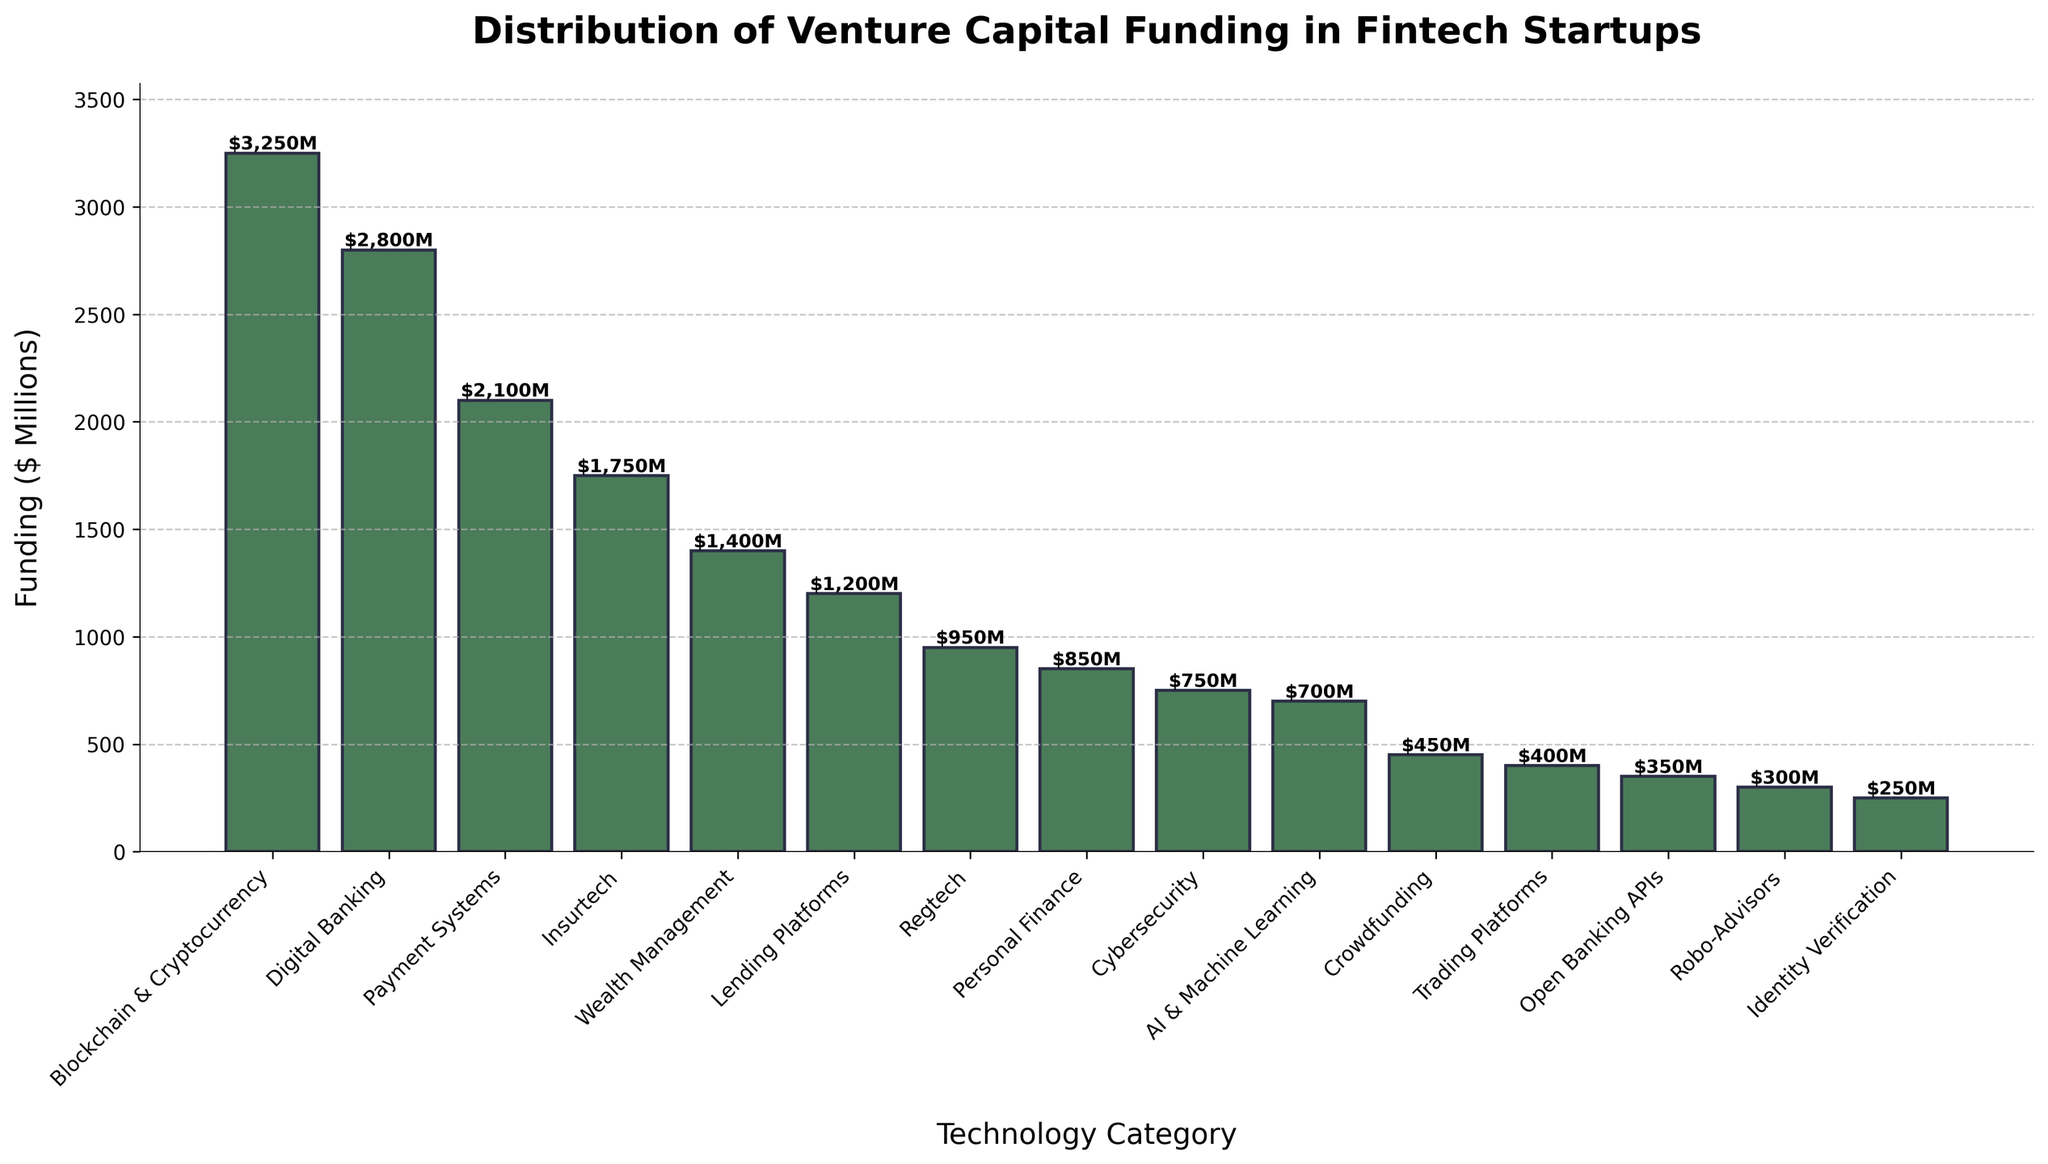What technology category received the most venture capital funding? The category with the tallest bar represents the highest funding. Here, "Blockchain & Cryptocurrency" has the tallest bar indicating it received the most funding.
Answer: Blockchain & Cryptocurrency Which two categories combined have the highest funding? To find the combined funding, add the amounts for different categories. The top two funded categories are "Blockchain & Cryptocurrency" ($3250M) and "Digital Banking" ($2800M). Combining these: $3250M + $2800M = $6050M.
Answer: Blockchain & Cryptocurrency and Digital Banking What is the difference in funding between Payment Systems and Lending Platforms? Locate the bars for "Payment Systems" and "Lending Platforms". "Payment Systems" received $2100M and "Lending Platforms" got $1200M. The difference is $2100M - $1200M = $900M.
Answer: $900M How much more funding did Digital Banking receive than Robo-Advisors? Check the height of the bars for both categories. "Digital Banking" got $2800M while "Robo-Advisors" received $300M. Difference: $2800M - $300M = $2500M.
Answer: $2500M Which category has the least funding, and how much is it? The category with the shortest bar represents the least funding. "Identity Verification" has the shortest bar, corresponding to $250M.
Answer: Identity Verification, $250M What is the average funding across all categories? Sum all the funding amounts and divide by the number of categories. Total funding: $3250M + $2800M + $2100M + $1750M + $1400M + $1200M + $950M + $850M + $750M + $700M + $450M + $400M + $350M + $300M + $250M = $20,500M. Number of categories = 15. Average = $20,500M / 15 ≈ $1367M.
Answer: $1367M Which category has a visually distinctive color compared to others? All categories use the same color for consistency. The visual distinction is achieved primarily through the height of the bars rather than different colors.
Answer: None (All use same color) What is the combined funding for categories receiving less than $1000M each? Identify categories with funding < $1000M: "Regtech" ($950M), "Personal Finance" ($850M), "Cybersecurity" ($750M), "AI & Machine Learning" ($700M), "Crowdfunding" ($450M), "Trading Platforms" ($400M), "Open Banking APIs" ($350M), "Robo-Advisors" ($300M), and "Identity Verification" ($250M). Sum: $950M + $850M + $750M + $700M + $450M + $400M + $350M + $300M + $250M = $5000M.
Answer: $5000M How many categories received more than double the funding of AI & Machine Learning? AI & Machine Learning received $700M. Double of this amount is $1400M. Categories with more than $1400M: "Blockchain & Cryptocurrency" ($3250M), "Digital Banking" ($2800M), "Payment Systems" ($2100M), and "Insurtech" ($1750M). Count: 4.
Answer: 4 